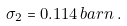Convert formula to latex. <formula><loc_0><loc_0><loc_500><loc_500>\sigma _ { 2 } = 0 . 1 1 4 \, b a r n \, .</formula> 